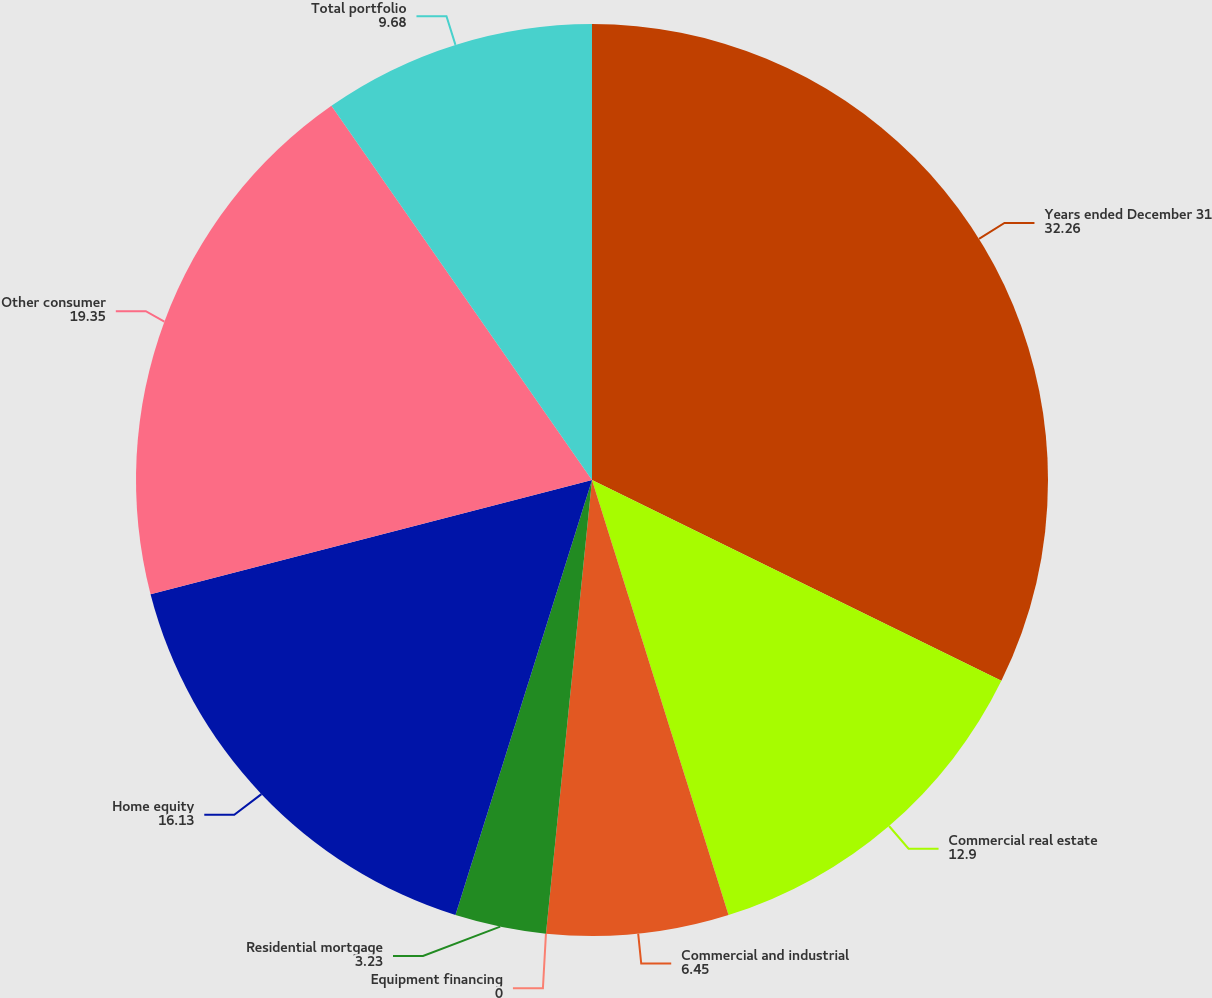Convert chart to OTSL. <chart><loc_0><loc_0><loc_500><loc_500><pie_chart><fcel>Years ended December 31<fcel>Commercial real estate<fcel>Commercial and industrial<fcel>Equipment financing<fcel>Residential mortgage<fcel>Home equity<fcel>Other consumer<fcel>Total portfolio<nl><fcel>32.26%<fcel>12.9%<fcel>6.45%<fcel>0.0%<fcel>3.23%<fcel>16.13%<fcel>19.35%<fcel>9.68%<nl></chart> 